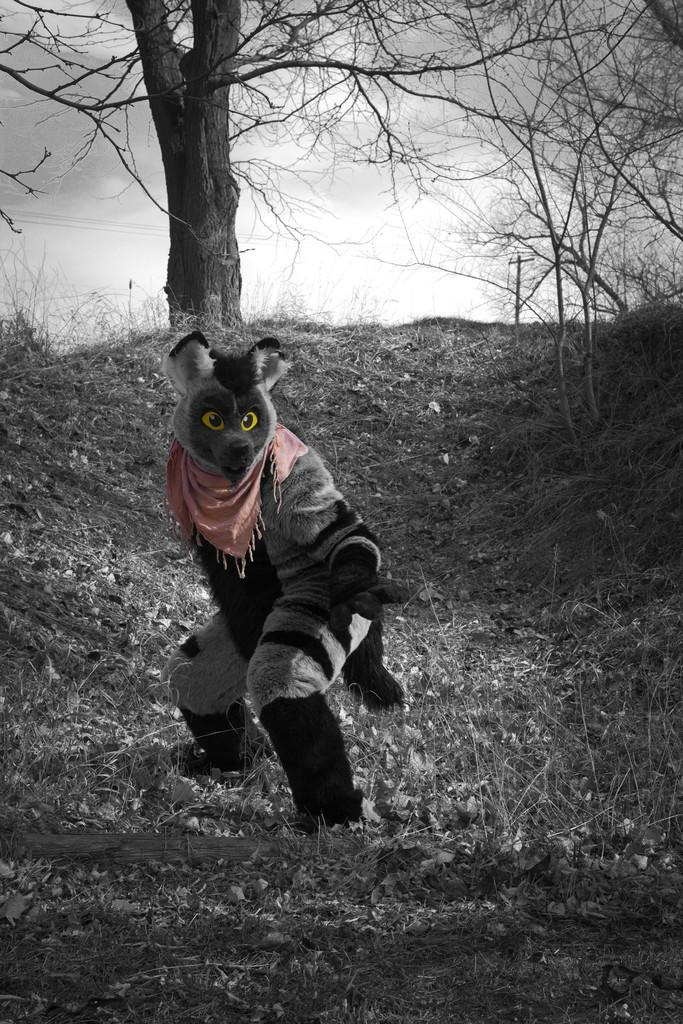What is the main subject of the image? There is a person in the image. What is the person wearing? The person is wearing an animal costume. Where is the person standing? The person is standing on the grass. What type of natural environment is visible in the image? Trees are present in the image. What type of ink can be seen spilling from the mine in the image? There is no ink or mine present in the image; it features a person wearing an animal costume standing on the grass with trees in the background. 